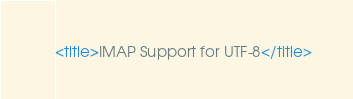Convert code to text. <code><loc_0><loc_0><loc_500><loc_500><_XML_><title>IMAP Support for UTF-8</title></code> 